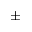Convert formula to latex. <formula><loc_0><loc_0><loc_500><loc_500>\pm</formula> 